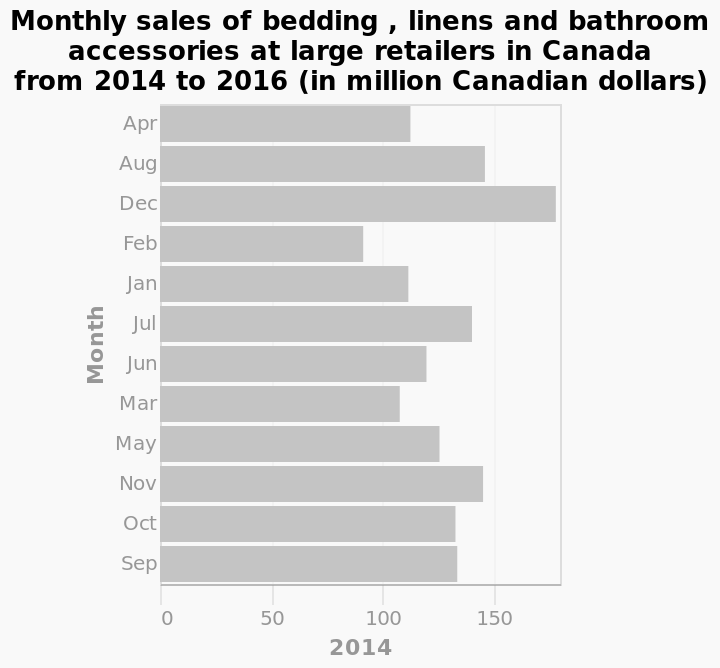<image>
Describe the following image in detail This is a bar diagram named Monthly sales of bedding , linens and bathroom accessories at large retailers in Canada from 2014 to 2016 (in million Canadian dollars). On the y-axis, Month is shown. The x-axis plots 2014. Which month had the lowest sales?  February. What does the x-axis plot in the bar diagram? The x-axis of the bar diagram plots the year 2014. Does the y-axis of the bar diagram plots the year 2014? No.The x-axis of the bar diagram plots the year 2014. 